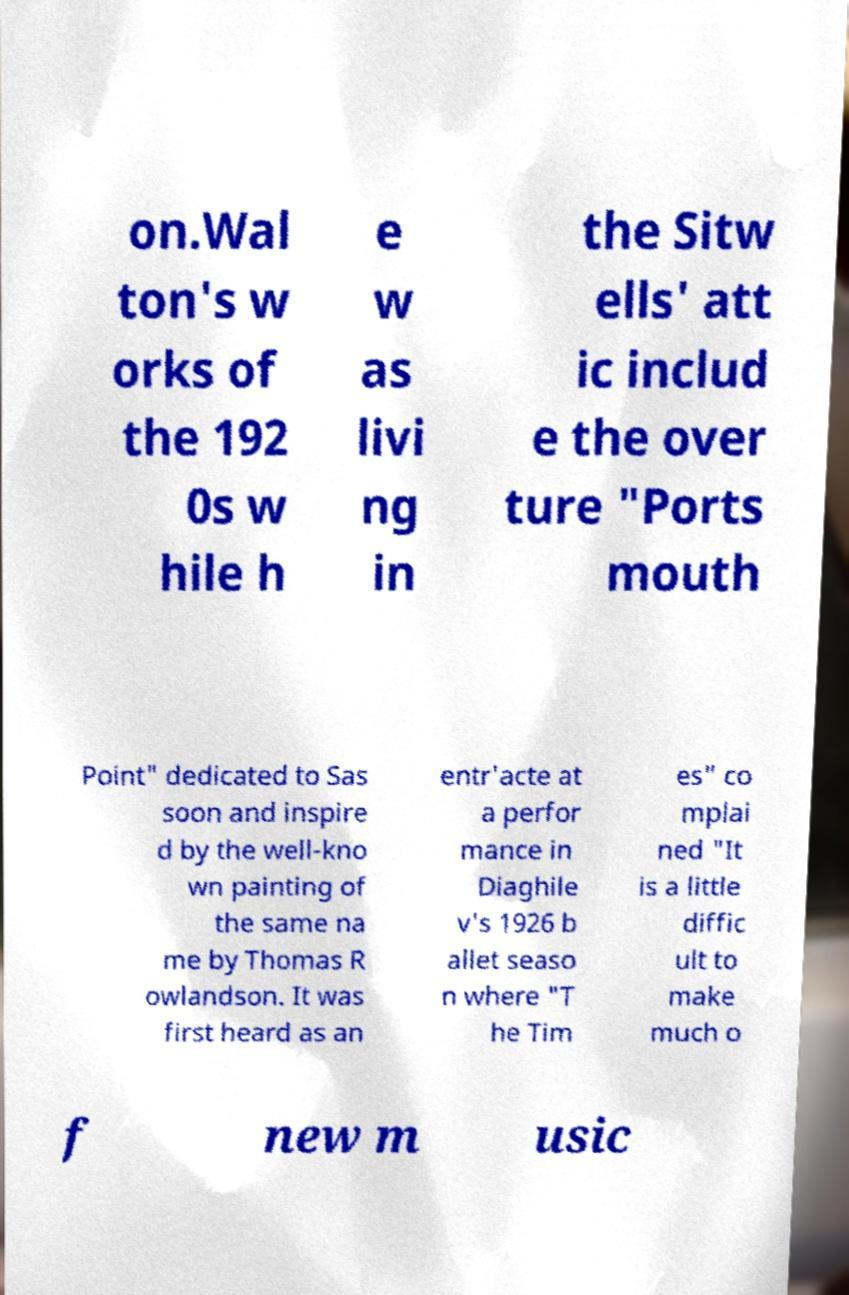I need the written content from this picture converted into text. Can you do that? on.Wal ton's w orks of the 192 0s w hile h e w as livi ng in the Sitw ells' att ic includ e the over ture "Ports mouth Point" dedicated to Sas soon and inspire d by the well-kno wn painting of the same na me by Thomas R owlandson. It was first heard as an entr'acte at a perfor mance in Diaghile v's 1926 b allet seaso n where "T he Tim es" co mplai ned "It is a little diffic ult to make much o f new m usic 